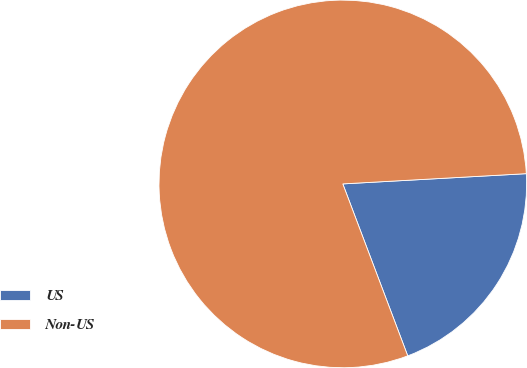Convert chart. <chart><loc_0><loc_0><loc_500><loc_500><pie_chart><fcel>US<fcel>Non-US<nl><fcel>20.14%<fcel>79.86%<nl></chart> 